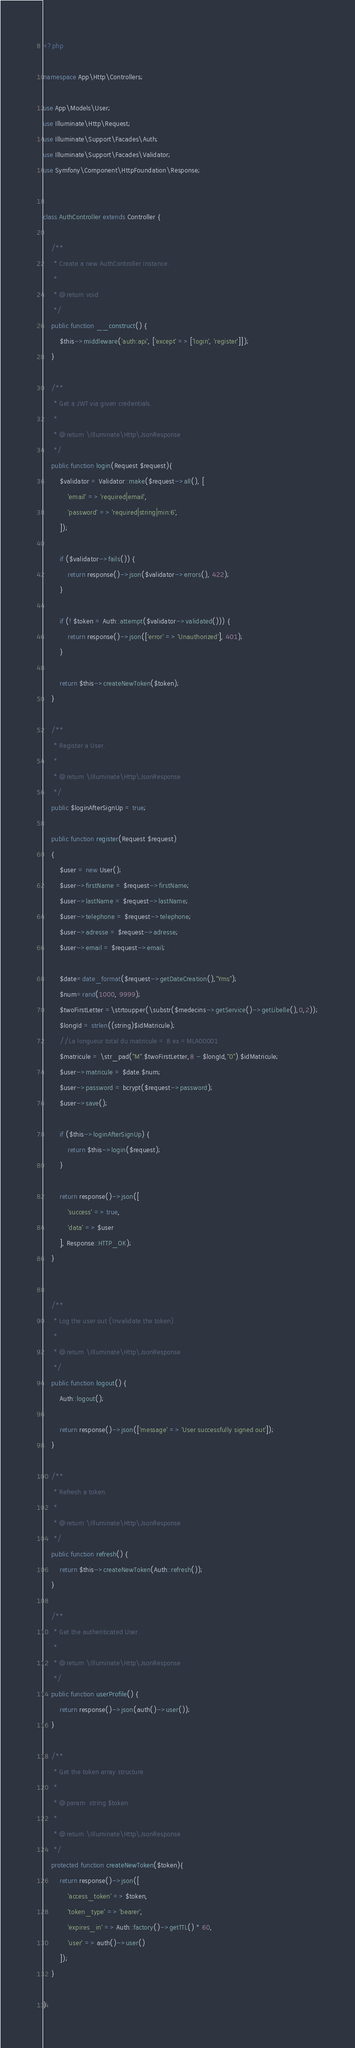<code> <loc_0><loc_0><loc_500><loc_500><_PHP_><?php

namespace App\Http\Controllers;

use App\Models\User;
use Illuminate\Http\Request;
use Illuminate\Support\Facades\Auth;
use Illuminate\Support\Facades\Validator;
use Symfony\Component\HttpFoundation\Response;


class AuthController extends Controller {

    /**
     * Create a new AuthController instance.
     *
     * @return void
     */
    public function __construct() {
        $this->middleware('auth:api', ['except' => ['login', 'register']]);
    }

    /**
     * Get a JWT via given credentials.
     *
     * @return \Illuminate\Http\JsonResponse
     */
    public function login(Request $request){
    	$validator = Validator::make($request->all(), [
            'email' => 'required|email',
            'password' => 'required|string|min:6',
        ]);

        if ($validator->fails()) {
            return response()->json($validator->errors(), 422);
        }

        if (! $token = Auth::attempt($validator->validated())) {
            return response()->json(['error' => 'Unauthorized'], 401);
        }

        return $this->createNewToken($token);
    }

    /**
     * Register a User.
     *
     * @return \Illuminate\Http\JsonResponse
     */
    public $loginAfterSignUp = true;

    public function register(Request $request)
    {
        $user = new User();
        $user->firstName = $request->firstName;
        $user->lastName = $request->lastName;
        $user->telephone = $request->telephone;
        $user->adresse = $request->adresse;
        $user->email = $request->email;

        $date=date_format($request->getDateCreation(),"Yms");
        $num=rand(1000, 9999);
        $twoFirstLetter =\strtoupper(\substr($medecins->getService()->getLibelle(),0,2));
        $longId = strlen((string)$idMatricule);
        //La longueur total du matricule = 8 ex =MLA00001
        $matricule = \str_pad("M".$twoFirstLetter,8 - $longId,"0").$idMatricule;
        $user->matricule = $date.$num;
        $user->password = bcrypt($request->password);
        $user->save();

        if ($this->loginAfterSignUp) {
            return $this->login($request);
        }

        return response()->json([
            'success' => true,
            'data' => $user
        ], Response::HTTP_OK);
    }


    /**
     * Log the user out (Invalidate the token).
     *
     * @return \Illuminate\Http\JsonResponse
     */
    public function logout() {
        Auth::logout();

        return response()->json(['message' => 'User successfully signed out']);
    }

    /**
     * Refresh a token.
     *
     * @return \Illuminate\Http\JsonResponse
     */
    public function refresh() {
        return $this->createNewToken(Auth::refresh());
    }

    /**
     * Get the authenticated User.
     *
     * @return \Illuminate\Http\JsonResponse
     */
    public function userProfile() {
        return response()->json(auth()->user());
    }

    /**
     * Get the token array structure.
     *
     * @param  string $token
     *
     * @return \Illuminate\Http\JsonResponse
     */
    protected function createNewToken($token){
        return response()->json([
            'access_token' => $token,
            'token_type' => 'bearer',
            'expires_in' => Auth::factory()->getTTL() * 60,
            'user' => auth()->user()
        ]);
    }

}
</code> 